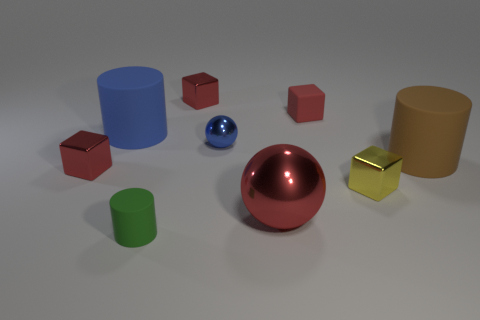Subtract all cyan cylinders. How many red blocks are left? 3 Add 1 blue cylinders. How many objects exist? 10 Subtract all cylinders. How many objects are left? 6 Subtract all tiny cyan objects. Subtract all big metallic things. How many objects are left? 8 Add 1 small green rubber cylinders. How many small green rubber cylinders are left? 2 Add 7 large red metal balls. How many large red metal balls exist? 8 Subtract 1 green cylinders. How many objects are left? 8 